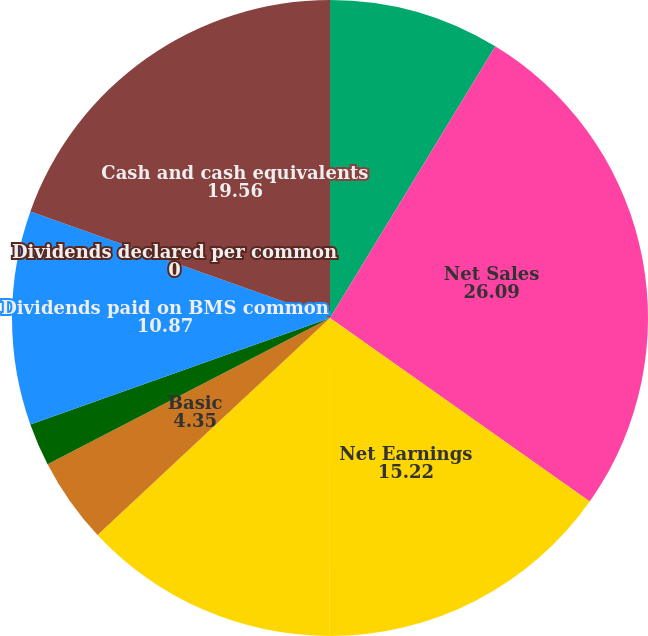Convert chart. <chart><loc_0><loc_0><loc_500><loc_500><pie_chart><fcel>Amounts in Millions except per<fcel>Net Sales<fcel>Net Earnings<fcel>Net Earnings Attributable to<fcel>Basic<fcel>Diluted<fcel>Dividends paid on BMS common<fcel>Dividends declared per common<fcel>Cash and cash equivalents<nl><fcel>8.7%<fcel>26.09%<fcel>15.22%<fcel>13.04%<fcel>4.35%<fcel>2.17%<fcel>10.87%<fcel>0.0%<fcel>19.56%<nl></chart> 